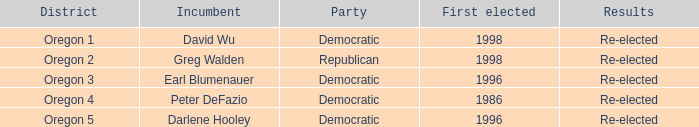Which democratic officeholder was initially elected in 1998? David Wu. Could you parse the entire table? {'header': ['District', 'Incumbent', 'Party', 'First elected', 'Results'], 'rows': [['Oregon 1', 'David Wu', 'Democratic', '1998', 'Re-elected'], ['Oregon 2', 'Greg Walden', 'Republican', '1998', 'Re-elected'], ['Oregon 3', 'Earl Blumenauer', 'Democratic', '1996', 'Re-elected'], ['Oregon 4', 'Peter DeFazio', 'Democratic', '1986', 'Re-elected'], ['Oregon 5', 'Darlene Hooley', 'Democratic', '1996', 'Re-elected']]} 